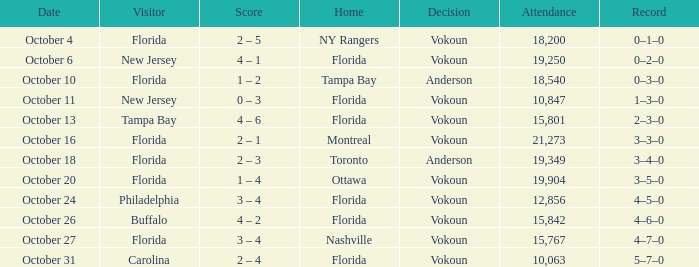What was the result of the game on october 13? 4 – 6. 